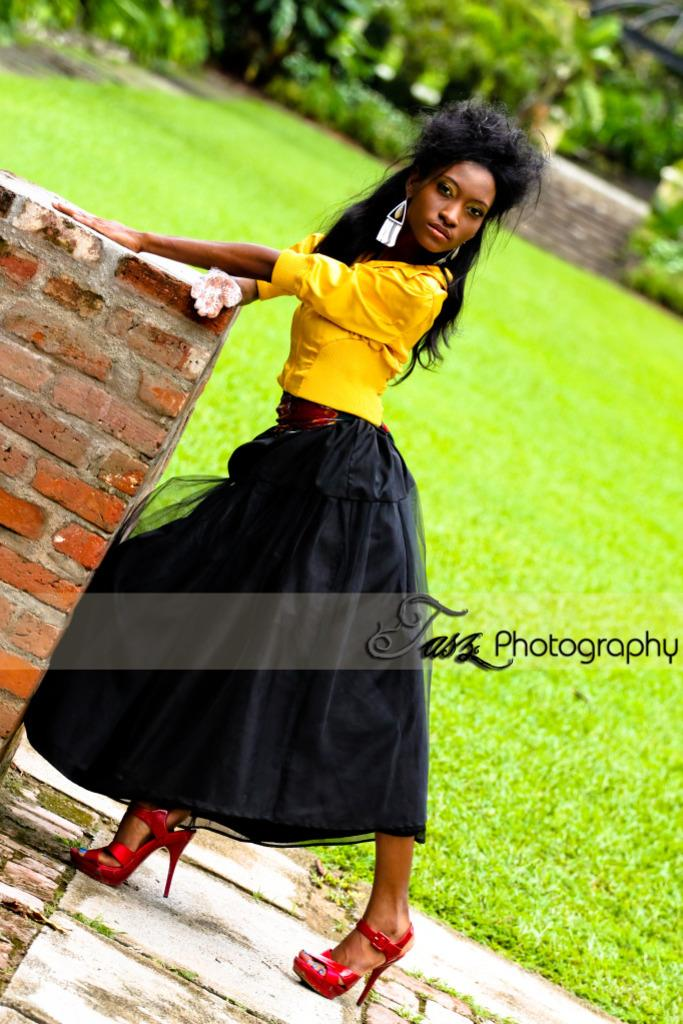What is the setting of the image? The image is an outside view. Can you describe the person in the image? There is a person in the image, and they are wearing clothes. What is the person's position in relation to the wall? The person is standing beside a wall. What type of creature can be seen hopping on the edge of the wall in the image? There is no creature hopping on the edge of the wall in the image; it only features a person standing beside a wall. 